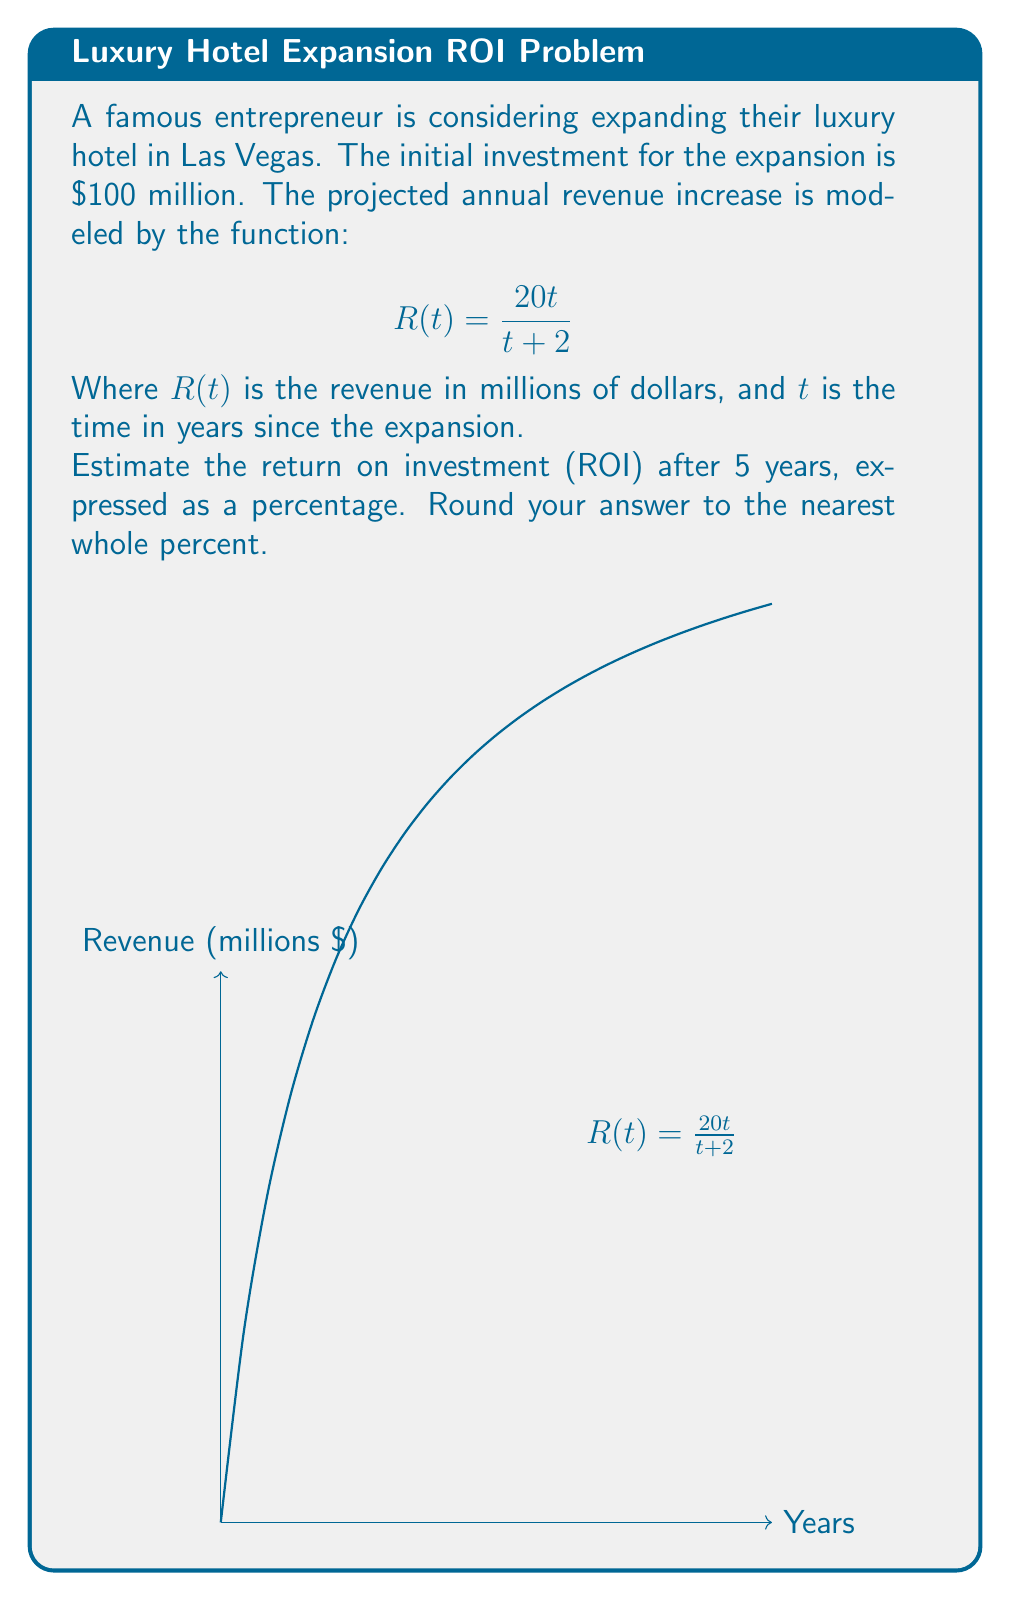Can you solve this math problem? Let's approach this step-by-step:

1) First, we need to calculate the total revenue over 5 years. We can do this by evaluating R(t) for t = 1, 2, 3, 4, and 5, and summing the results.

   $$R(1) = \frac{20(1)}{1+2} = \frac{20}{3} \approx 6.67$$
   $$R(2) = \frac{20(2)}{2+2} = 10$$
   $$R(3) = \frac{20(3)}{3+2} = 12$$
   $$R(4) = \frac{20(4)}{4+2} = \frac{80}{6} \approx 13.33$$
   $$R(5) = \frac{20(5)}{5+2} = \frac{100}{7} \approx 14.29$$

2) Total revenue = 6.67 + 10 + 12 + 13.33 + 14.29 ≈ 56.29 million

3) ROI is calculated as: 
   $$ROI = \frac{\text{Gain from Investment} - \text{Cost of Investment}}{\text{Cost of Investment}} \times 100\%$$

4) In this case:
   Gain from Investment = $56.29 million
   Cost of Investment = $100 million

5) Plugging these values into the ROI formula:
   $$ROI = \frac{56.29 - 100}{100} \times 100\% = -43.71\%$$

6) Rounding to the nearest whole percent: -44%
Answer: -44% 